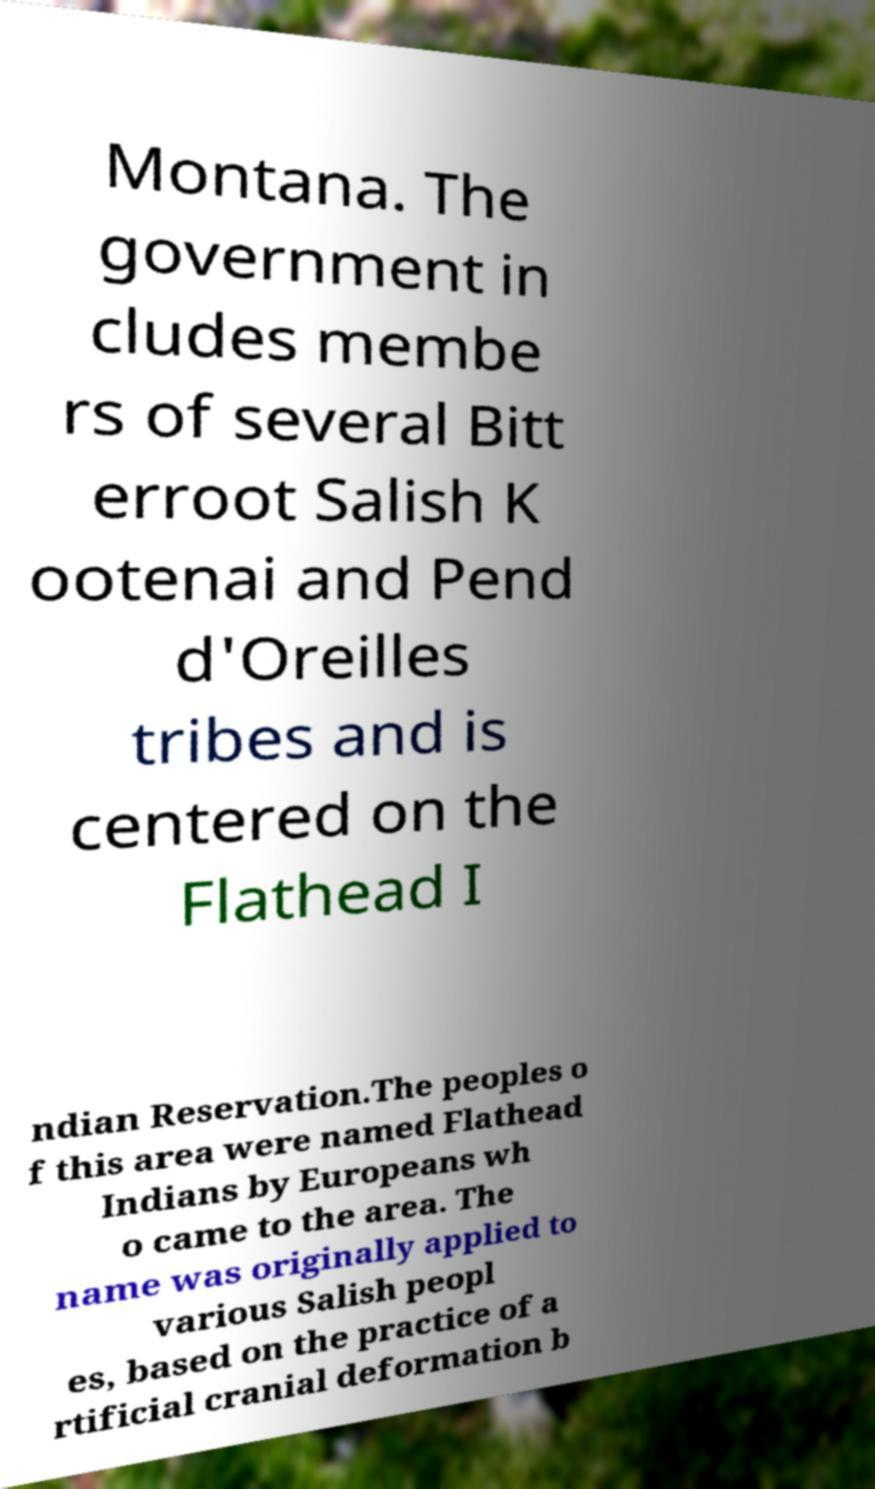There's text embedded in this image that I need extracted. Can you transcribe it verbatim? Montana. The government in cludes membe rs of several Bitt erroot Salish K ootenai and Pend d'Oreilles tribes and is centered on the Flathead I ndian Reservation.The peoples o f this area were named Flathead Indians by Europeans wh o came to the area. The name was originally applied to various Salish peopl es, based on the practice of a rtificial cranial deformation b 